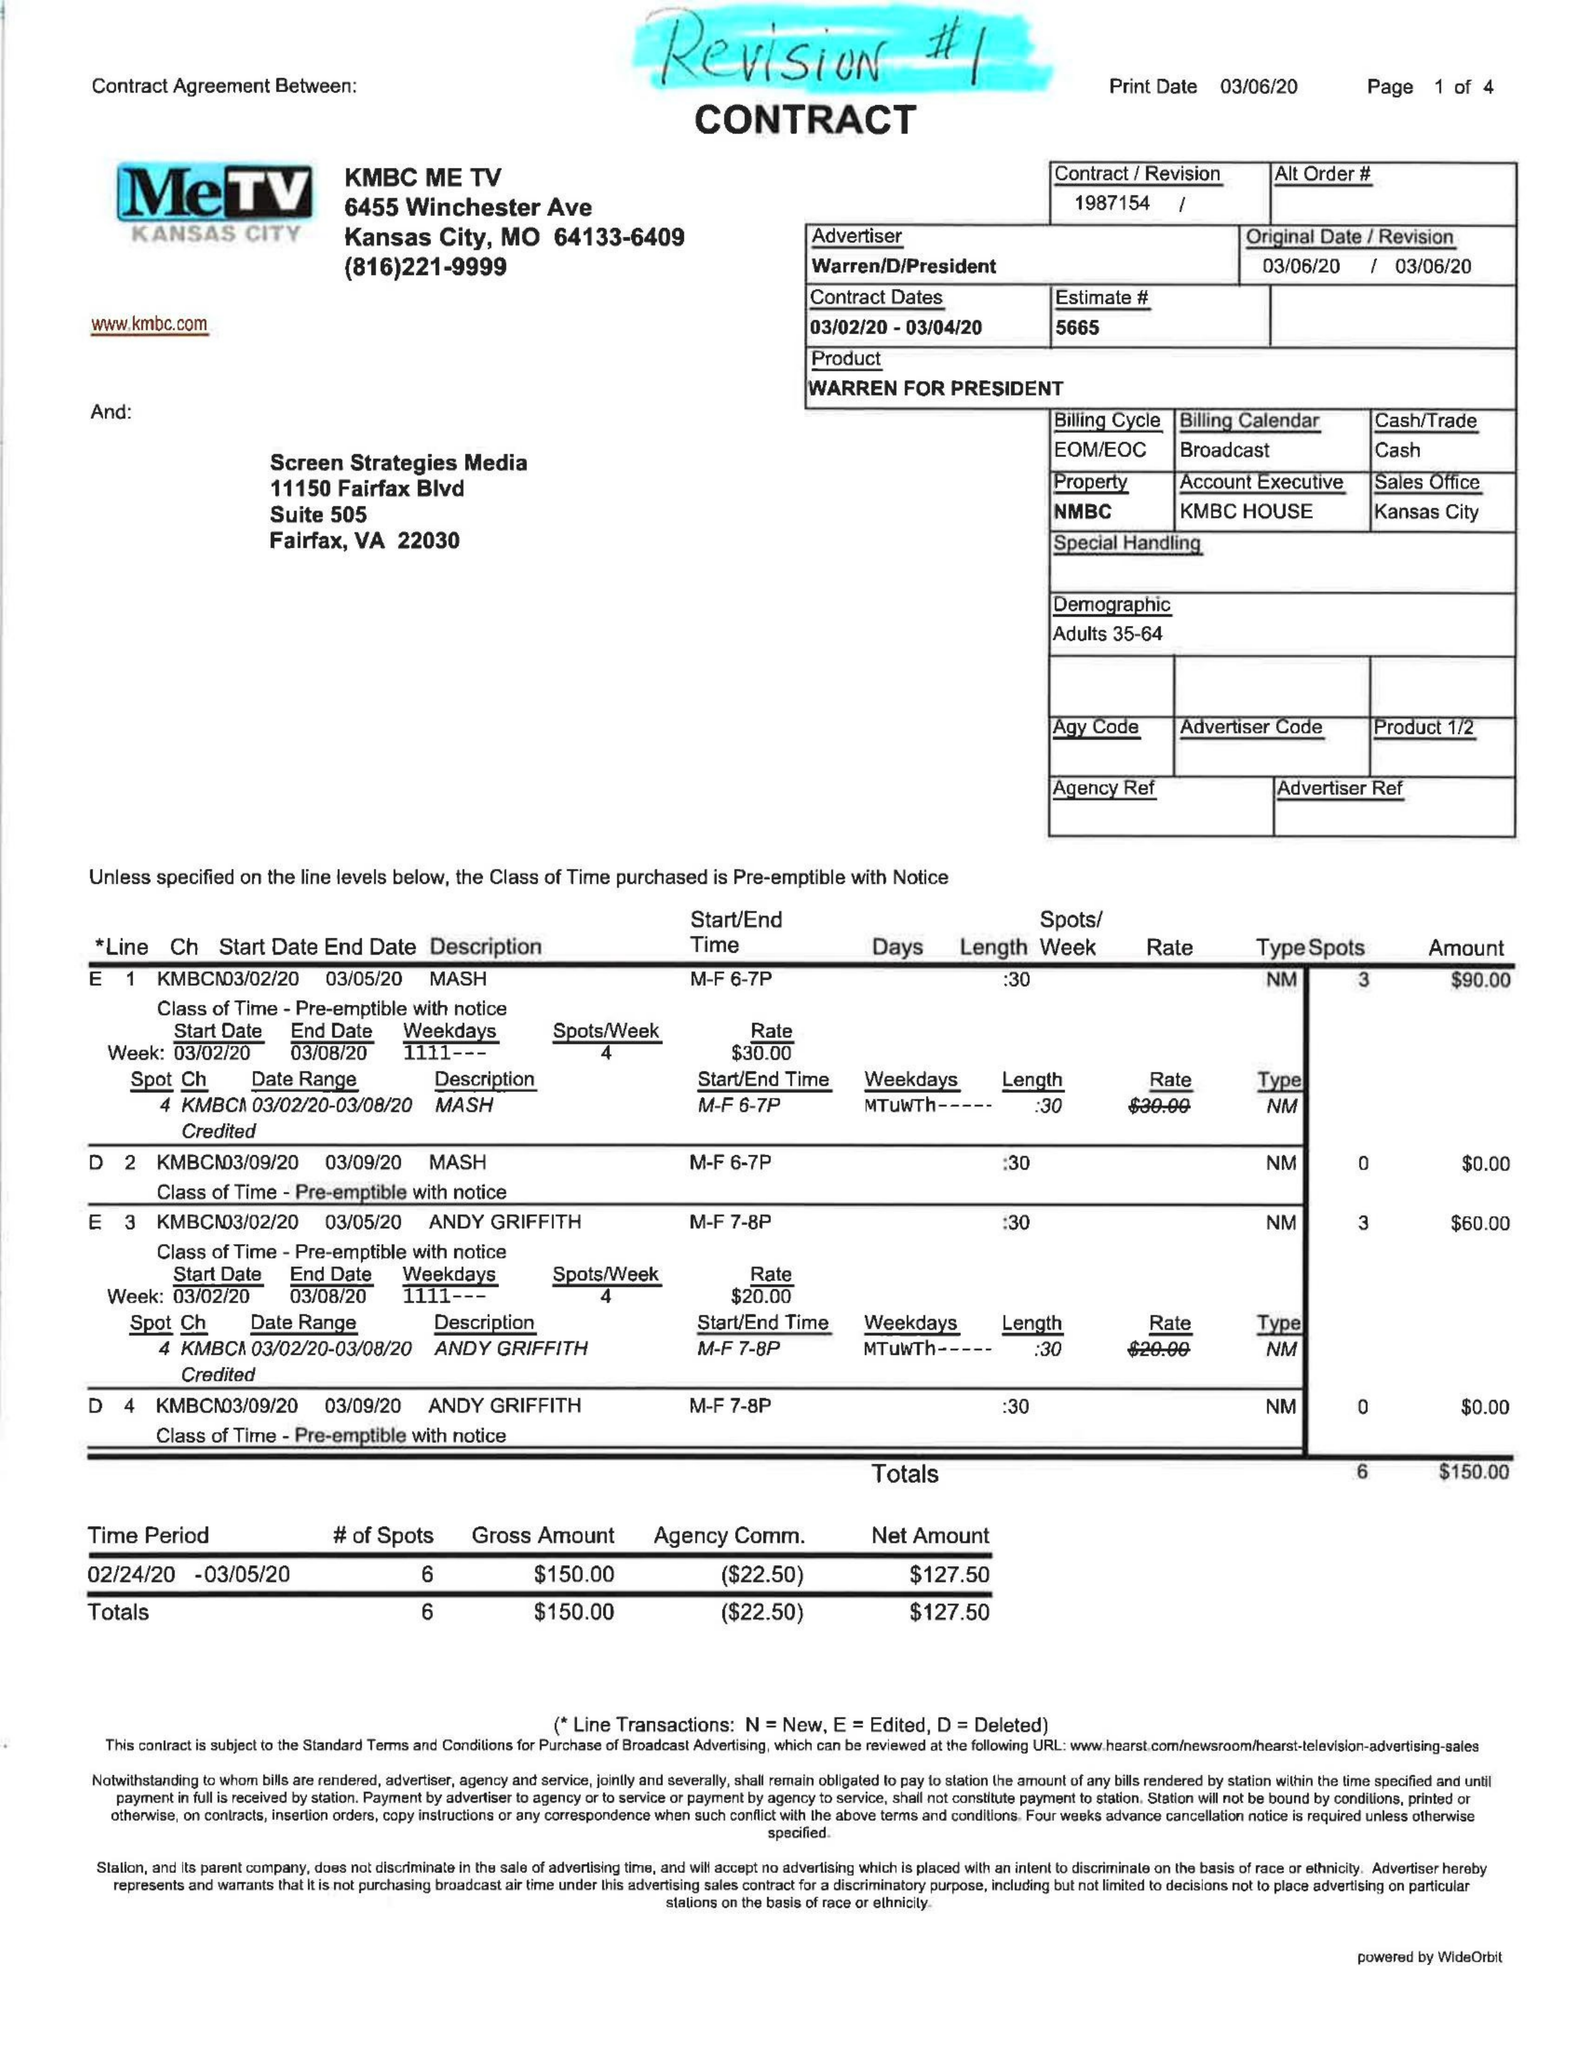What is the value for the gross_amount?
Answer the question using a single word or phrase. 150.00 